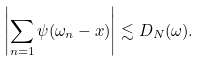Convert formula to latex. <formula><loc_0><loc_0><loc_500><loc_500>\left | \sum _ { n = 1 } \psi ( \omega _ { n } - x ) \right | \lesssim D _ { N } ( \omega ) .</formula> 